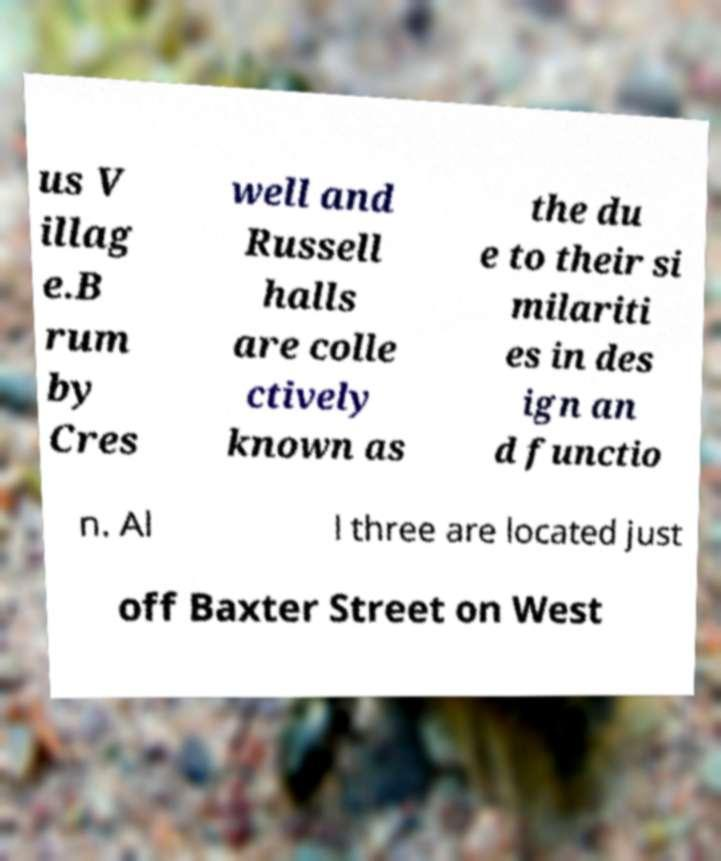For documentation purposes, I need the text within this image transcribed. Could you provide that? us V illag e.B rum by Cres well and Russell halls are colle ctively known as the du e to their si milariti es in des ign an d functio n. Al l three are located just off Baxter Street on West 